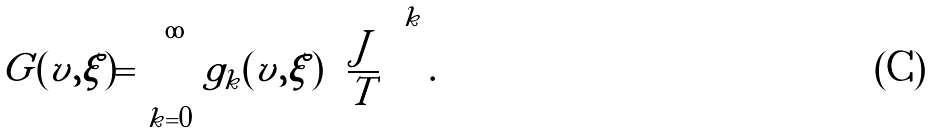Convert formula to latex. <formula><loc_0><loc_0><loc_500><loc_500>G ( v , \xi ) = \sum _ { k = 0 } ^ { \infty } g _ { k } ( v , \xi ) \left ( \frac { J } { T } \right ) ^ { k } .</formula> 